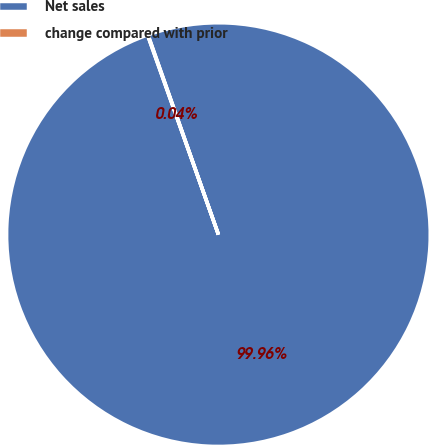Convert chart to OTSL. <chart><loc_0><loc_0><loc_500><loc_500><pie_chart><fcel>Net sales<fcel>change compared with prior<nl><fcel>99.96%<fcel>0.04%<nl></chart> 